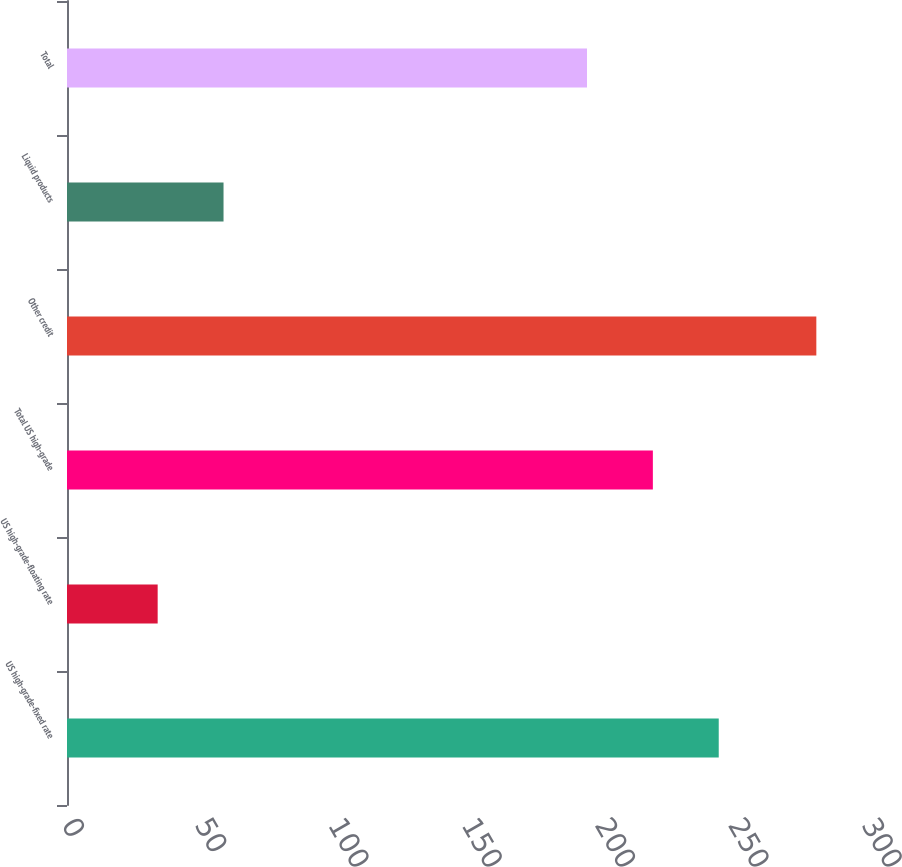Convert chart to OTSL. <chart><loc_0><loc_0><loc_500><loc_500><bar_chart><fcel>US high-grade-fixed rate<fcel>US high-grade-floating rate<fcel>Total US high-grade<fcel>Other credit<fcel>Liquid products<fcel>Total<nl><fcel>244.4<fcel>34<fcel>219.7<fcel>281<fcel>58.7<fcel>195<nl></chart> 